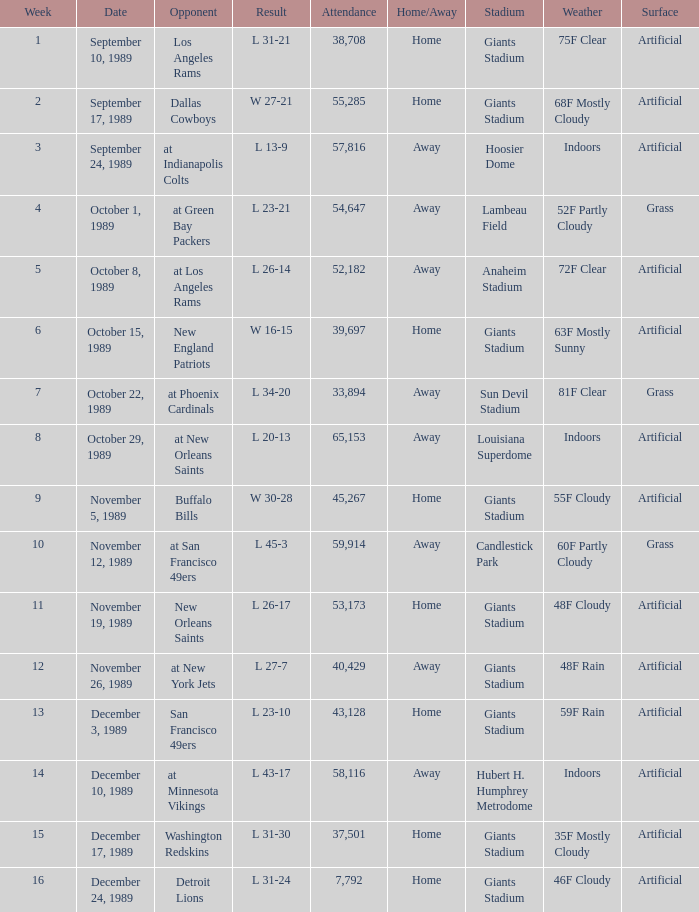The Detroit Lions were played against what week? 16.0. 